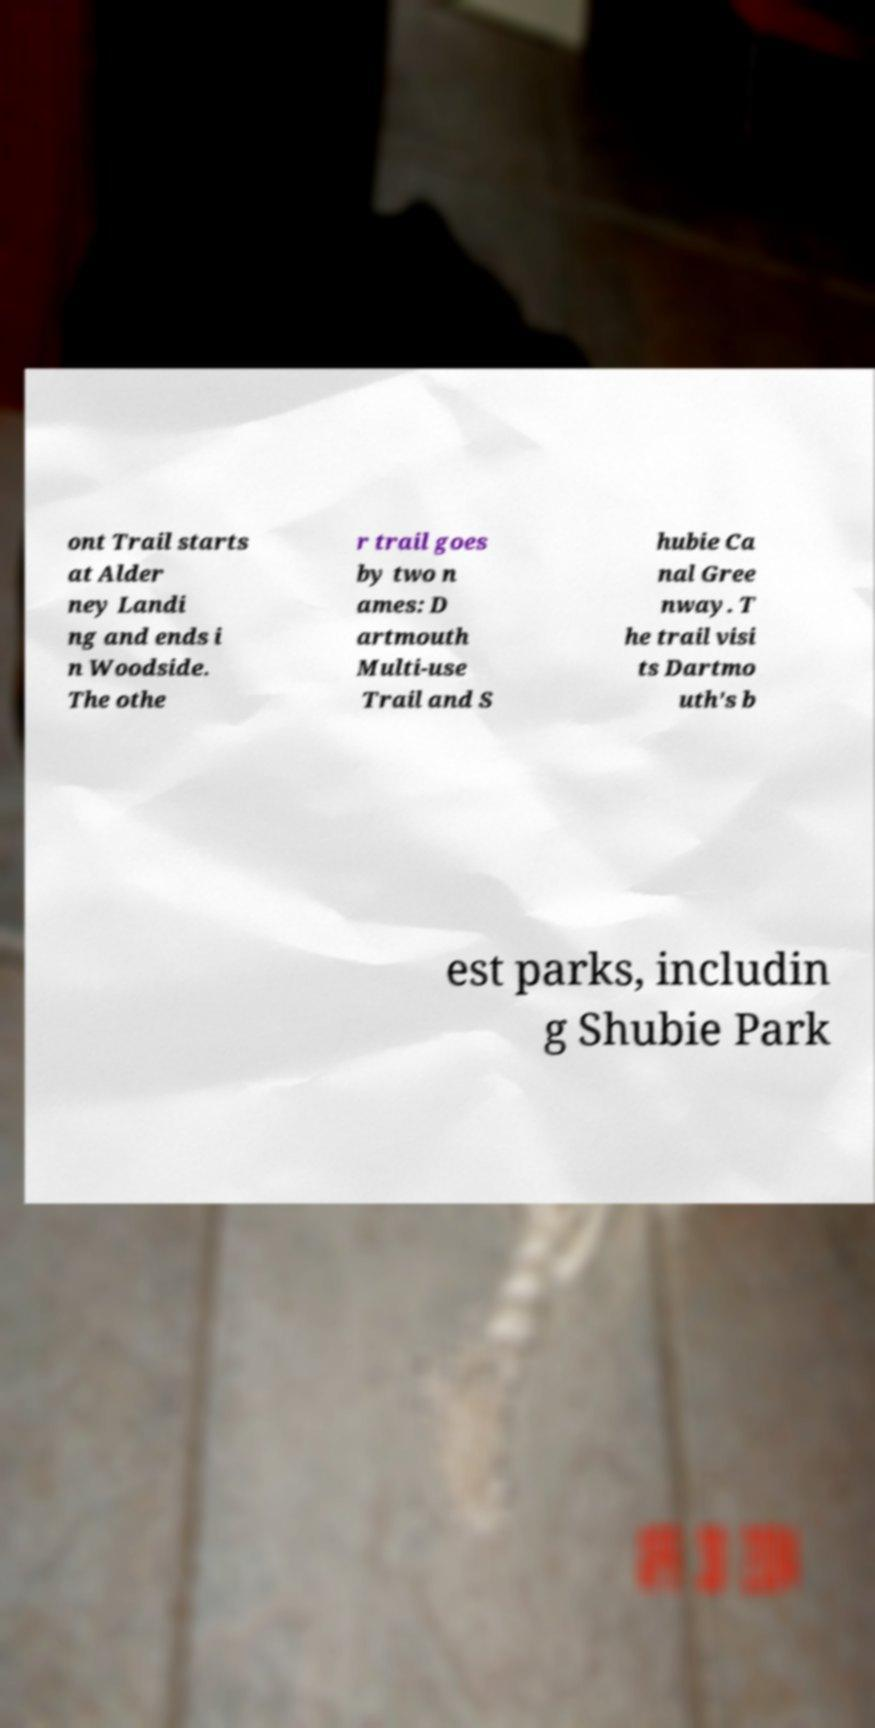Could you extract and type out the text from this image? ont Trail starts at Alder ney Landi ng and ends i n Woodside. The othe r trail goes by two n ames: D artmouth Multi-use Trail and S hubie Ca nal Gree nway. T he trail visi ts Dartmo uth's b est parks, includin g Shubie Park 